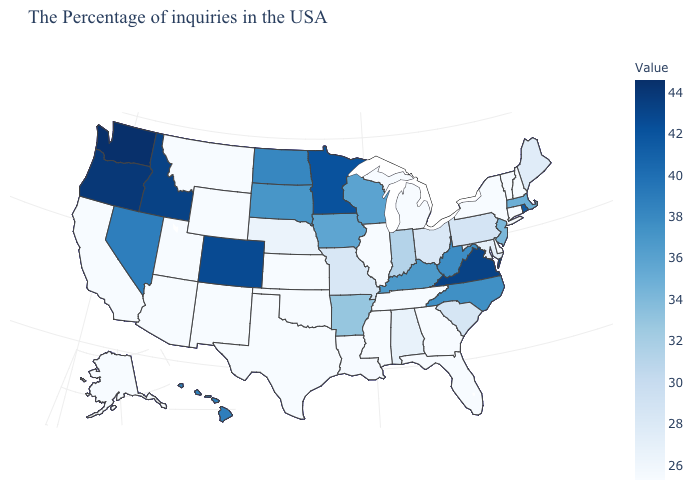Which states have the highest value in the USA?
Write a very short answer. Washington. Which states have the highest value in the USA?
Be succinct. Washington. Among the states that border Ohio , which have the highest value?
Be succinct. West Virginia. Does Virginia have the highest value in the South?
Quick response, please. Yes. Does New York have the lowest value in the USA?
Concise answer only. Yes. Which states have the lowest value in the USA?
Give a very brief answer. New Hampshire, Vermont, Connecticut, New York, Delaware, Florida, Georgia, Michigan, Tennessee, Illinois, Mississippi, Kansas, Oklahoma, Texas, Wyoming, New Mexico, Utah, Montana, Arizona, California, Alaska. Among the states that border Alabama , which have the highest value?
Write a very short answer. Florida, Georgia, Tennessee, Mississippi. 